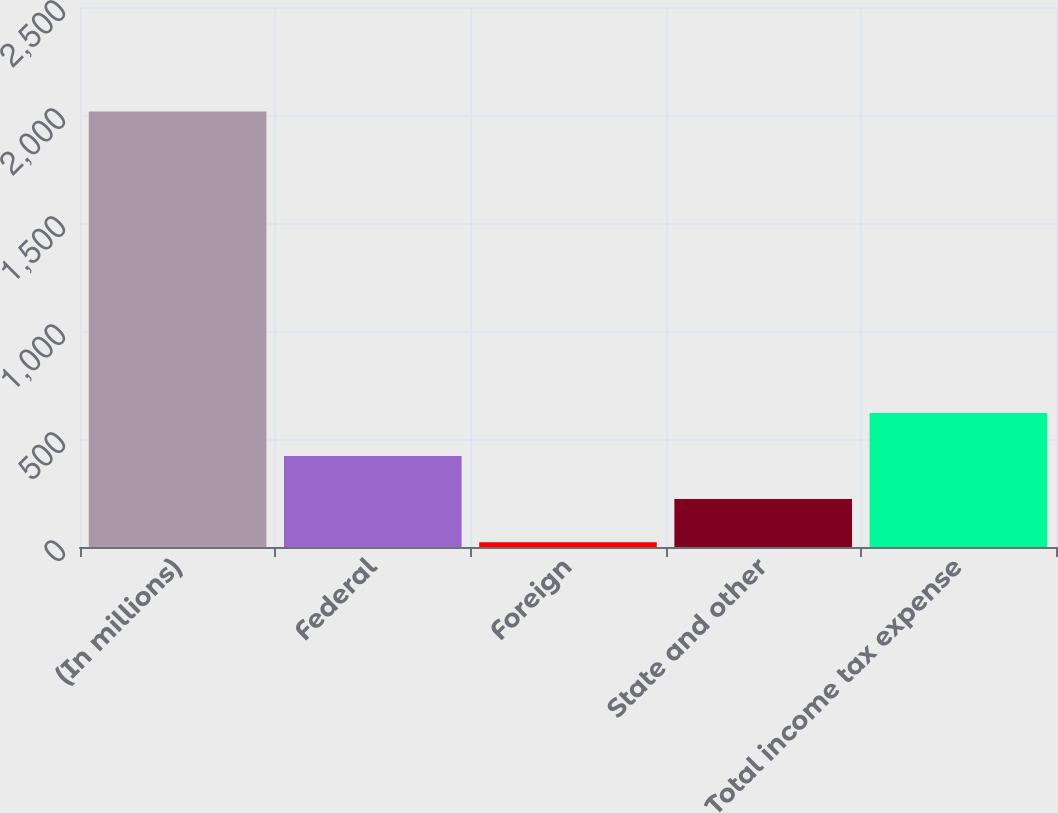Convert chart to OTSL. <chart><loc_0><loc_0><loc_500><loc_500><bar_chart><fcel>(In millions)<fcel>Federal<fcel>Foreign<fcel>State and other<fcel>Total income tax expense<nl><fcel>2016<fcel>421.04<fcel>22.3<fcel>221.67<fcel>620.41<nl></chart> 